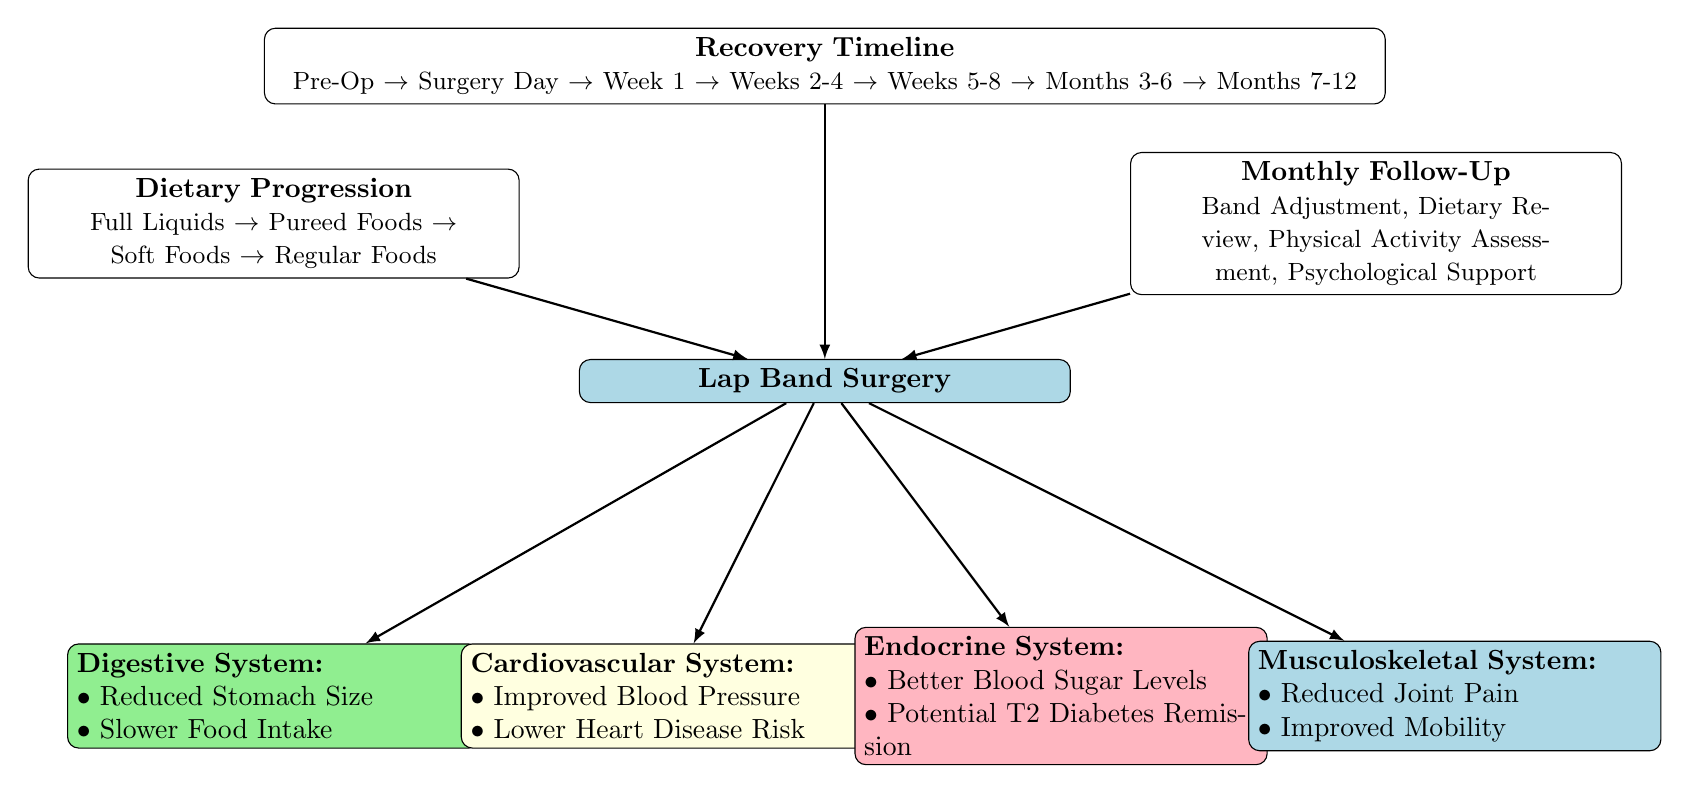What is the first milestone in the recovery timeline? The recovery timeline starts from the "Pre-Op" phase listed at the leftmost part of the timeline. It indicates that this is the initial stage before the surgery occurs.
Answer: Pre-Op How many body systems are affected by Lap Band surgery according to the diagram? The diagram lists four different body systems impacted by the surgery, which are the Digestive, Cardiovascular, Endocrine, and Musculoskeletal systems.
Answer: 4 What dietary phase comes after "Pureed Foods"? The diagram's dietary progression shows that the phase that follows "Pureed Foods" is "Soft Foods", providing a clear sequence of dietary changes post-surgery.
Answer: Soft Foods What key milestone occurs after Weeks 2-4 in the recovery timeline? According to the timeline, the next milestone after Weeks 2-4 is "Weeks 5-8", indicating a transition to the next phase of recovery.
Answer: Weeks 5-8 What is the main focus of the "Monthly Follow-Up" section? The "Monthly Follow-Up" section has several focuses, including Band Adjustment and Dietary Review, but the primary aspect is to support ongoing adjustments and evaluations after surgery.
Answer: Band Adjustment What effect does Lap Band surgery have on the Endocrine System? The Endocrine System is positively affected by Lap Band surgery, which is indicated by improved blood sugar levels and the potential for type 2 diabetes remission.
Answer: Better Blood Sugar Levels Which system is associated with reduced joint pain? The system that is linked to reduced joint pain as a result of Lap Band surgery is the Musculoskeletal System, highlighting the surgery's benefits for physical mobility.
Answer: Musculoskeletal System What change occurs in the Digestive System post-surgery? The diagram indicates that one of the key changes in the Digestive System after Lap Band surgery is a reduced stomach size, which affects food intake capacity.
Answer: Reduced Stomach Size 